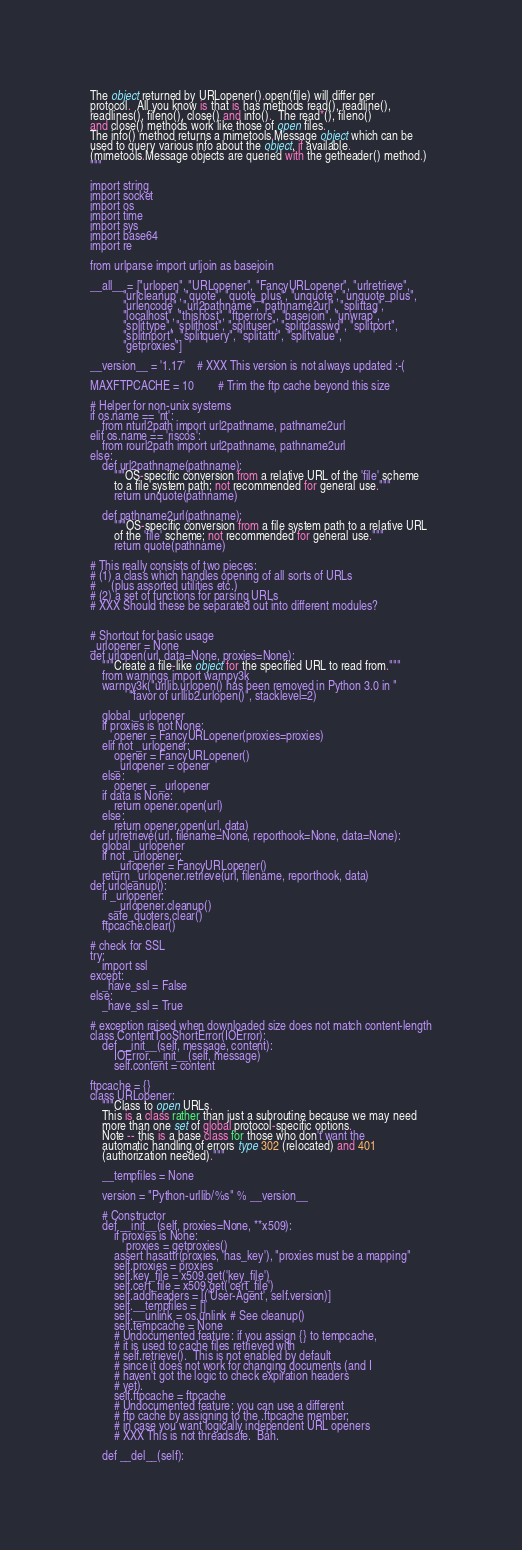<code> <loc_0><loc_0><loc_500><loc_500><_Python_>
The object returned by URLopener().open(file) will differ per
protocol.  All you know is that is has methods read(), readline(),
readlines(), fileno(), close() and info().  The read*(), fileno()
and close() methods work like those of open files.
The info() method returns a mimetools.Message object which can be
used to query various info about the object, if available.
(mimetools.Message objects are queried with the getheader() method.)
"""

import string
import socket
import os
import time
import sys
import base64
import re

from urlparse import urljoin as basejoin

__all__ = ["urlopen", "URLopener", "FancyURLopener", "urlretrieve",
           "urlcleanup", "quote", "quote_plus", "unquote", "unquote_plus",
           "urlencode", "url2pathname", "pathname2url", "splittag",
           "localhost", "thishost", "ftperrors", "basejoin", "unwrap",
           "splittype", "splithost", "splituser", "splitpasswd", "splitport",
           "splitnport", "splitquery", "splitattr", "splitvalue",
           "getproxies"]

__version__ = '1.17'    # XXX This version is not always updated :-(

MAXFTPCACHE = 10        # Trim the ftp cache beyond this size

# Helper for non-unix systems
if os.name == 'nt':
    from nturl2path import url2pathname, pathname2url
elif os.name == 'riscos':
    from rourl2path import url2pathname, pathname2url
else:
    def url2pathname(pathname):
        """OS-specific conversion from a relative URL of the 'file' scheme
        to a file system path; not recommended for general use."""
        return unquote(pathname)

    def pathname2url(pathname):
        """OS-specific conversion from a file system path to a relative URL
        of the 'file' scheme; not recommended for general use."""
        return quote(pathname)

# This really consists of two pieces:
# (1) a class which handles opening of all sorts of URLs
#     (plus assorted utilities etc.)
# (2) a set of functions for parsing URLs
# XXX Should these be separated out into different modules?


# Shortcut for basic usage
_urlopener = None
def urlopen(url, data=None, proxies=None):
    """Create a file-like object for the specified URL to read from."""
    from warnings import warnpy3k
    warnpy3k("urllib.urlopen() has been removed in Python 3.0 in "
             "favor of urllib2.urlopen()", stacklevel=2)

    global _urlopener
    if proxies is not None:
        opener = FancyURLopener(proxies=proxies)
    elif not _urlopener:
        opener = FancyURLopener()
        _urlopener = opener
    else:
        opener = _urlopener
    if data is None:
        return opener.open(url)
    else:
        return opener.open(url, data)
def urlretrieve(url, filename=None, reporthook=None, data=None):
    global _urlopener
    if not _urlopener:
        _urlopener = FancyURLopener()
    return _urlopener.retrieve(url, filename, reporthook, data)
def urlcleanup():
    if _urlopener:
        _urlopener.cleanup()
    _safe_quoters.clear()
    ftpcache.clear()

# check for SSL
try:
    import ssl
except:
    _have_ssl = False
else:
    _have_ssl = True

# exception raised when downloaded size does not match content-length
class ContentTooShortError(IOError):
    def __init__(self, message, content):
        IOError.__init__(self, message)
        self.content = content

ftpcache = {}
class URLopener:
    """Class to open URLs.
    This is a class rather than just a subroutine because we may need
    more than one set of global protocol-specific options.
    Note -- this is a base class for those who don't want the
    automatic handling of errors type 302 (relocated) and 401
    (authorization needed)."""

    __tempfiles = None

    version = "Python-urllib/%s" % __version__

    # Constructor
    def __init__(self, proxies=None, **x509):
        if proxies is None:
            proxies = getproxies()
        assert hasattr(proxies, 'has_key'), "proxies must be a mapping"
        self.proxies = proxies
        self.key_file = x509.get('key_file')
        self.cert_file = x509.get('cert_file')
        self.addheaders = [('User-Agent', self.version)]
        self.__tempfiles = []
        self.__unlink = os.unlink # See cleanup()
        self.tempcache = None
        # Undocumented feature: if you assign {} to tempcache,
        # it is used to cache files retrieved with
        # self.retrieve().  This is not enabled by default
        # since it does not work for changing documents (and I
        # haven't got the logic to check expiration headers
        # yet).
        self.ftpcache = ftpcache
        # Undocumented feature: you can use a different
        # ftp cache by assigning to the .ftpcache member;
        # in case you want logically independent URL openers
        # XXX This is not threadsafe.  Bah.

    def __del__(self):</code> 